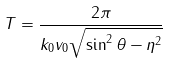Convert formula to latex. <formula><loc_0><loc_0><loc_500><loc_500>T = \frac { 2 \pi } { k _ { 0 } v _ { 0 } \sqrt { \sin ^ { 2 } \theta - \eta ^ { 2 } } }</formula> 